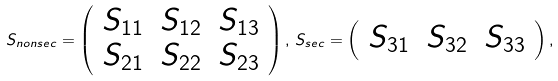<formula> <loc_0><loc_0><loc_500><loc_500>S _ { n o n s e c } = \left ( \begin{array} { c c c } S _ { 1 1 } & S _ { 1 2 } & S _ { 1 3 } \\ S _ { 2 1 } & S _ { 2 2 } & S _ { 2 3 } \\ \end{array} \right ) , \, S _ { s e c } = \left ( \begin{array} { c c c } S _ { 3 1 } & S _ { 3 2 } & S _ { 3 3 } \end{array} \right ) ,</formula> 